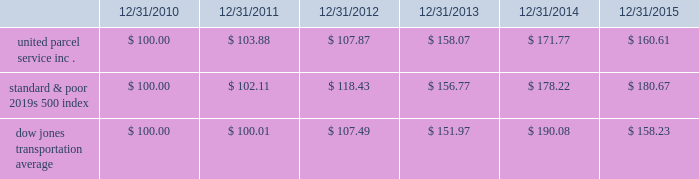Shareowner return performance graph the following performance graph and related information shall not be deemed 201csoliciting material 201d or to be 201cfiled 201d with the sec , nor shall such information be incorporated by reference into any future filing under the securities act of 1933 or securities exchange act of 1934 , each as amended , except to the extent that the company specifically incorporates such information by reference into such filing .
The following graph shows a five year comparison of cumulative total shareowners 2019 returns for our class b common stock , the standard & poor 2019s 500 index , and the dow jones transportation average .
The comparison of the total cumulative return on investment , which is the change in the quarterly stock price plus reinvested dividends for each of the quarterly periods , assumes that $ 100 was invested on december 31 , 2010 in the standard & poor 2019s 500 index , the dow jones transportation average , and our class b common stock. .

What is the five year performance of ups class b common stock? 
Computations: ((160.61 - 100) / 100)
Answer: 0.6061. 